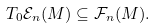Convert formula to latex. <formula><loc_0><loc_0><loc_500><loc_500>T _ { 0 } \mathcal { E } _ { n } ( M ) \subseteq \mathcal { F } _ { n } ( M ) .</formula> 